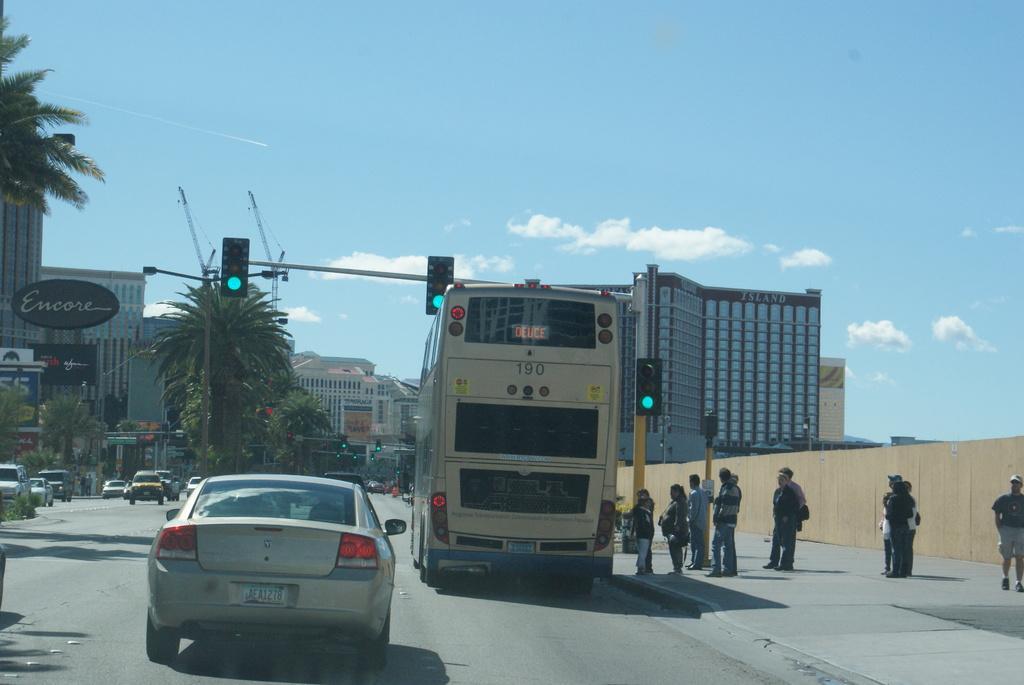In one or two sentences, can you explain what this image depicts? In this picture there are people and we can see vehicles on the road, traffic signals, boards, poles, trees and buildings. In the background of the image we can see the sky with clouds. 